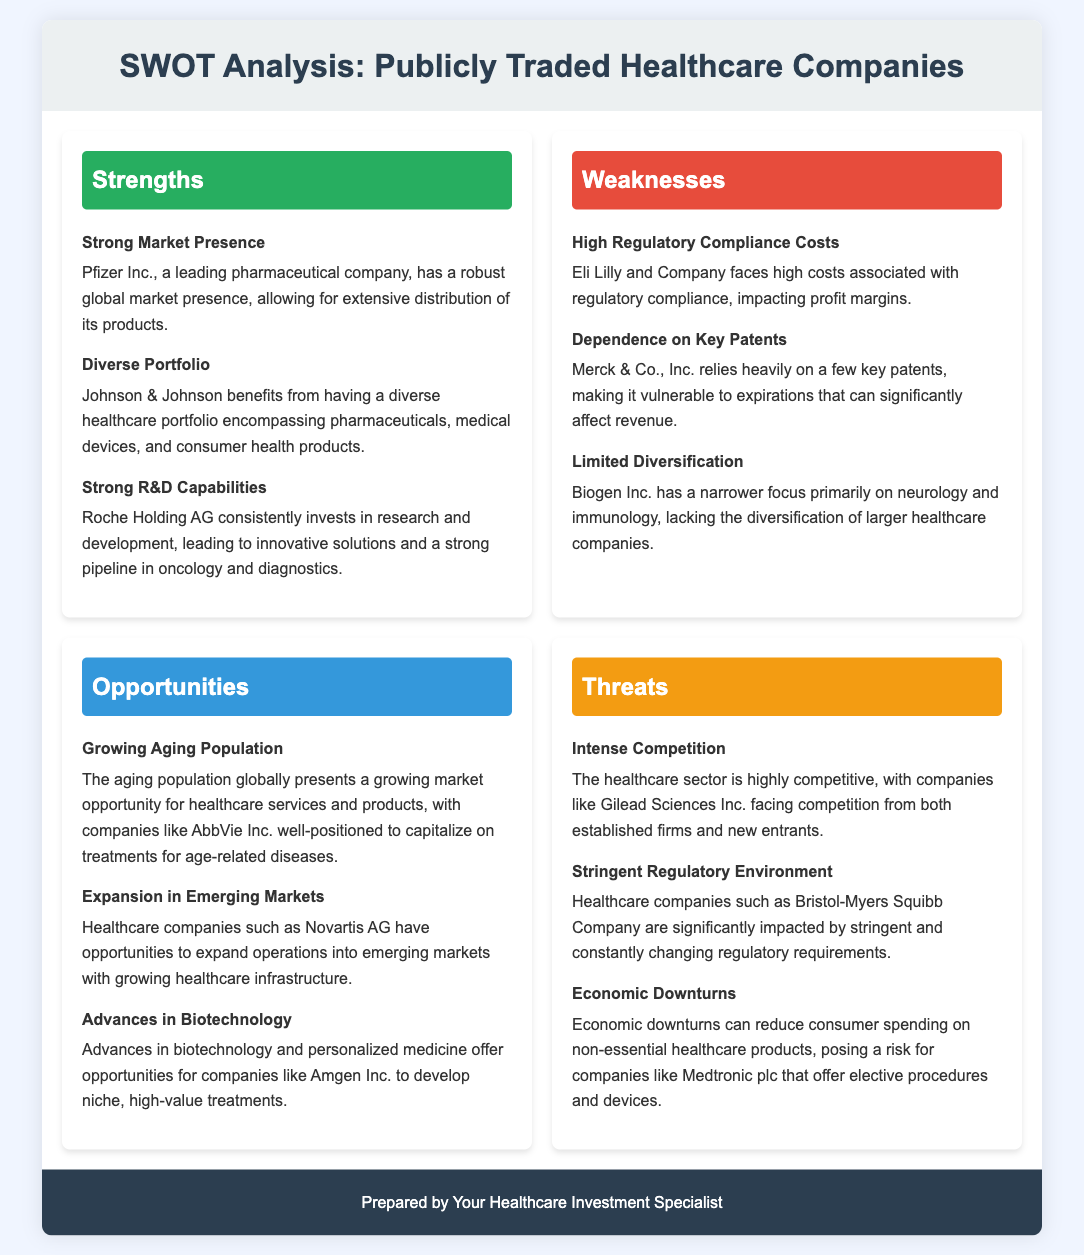What company has a strong market presence? Pfizer Inc. is mentioned as a leading pharmaceutical company with a robust global market presence.
Answer: Pfizer Inc Which company benefits from a diverse healthcare portfolio? Johnson & Johnson is highlighted for its diverse healthcare portfolio encompassing various sectors.
Answer: Johnson & Johnson What is a weakness associated with Eli Lilly and Company? The document states that Eli Lilly and Company faces high costs associated with regulatory compliance.
Answer: High Regulatory Compliance Costs Which company relies heavily on a few key patents? Merck & Co., Inc. is noted for its dependence on a few key patents, making it vulnerable to expirations.
Answer: Merck & Co., Inc What opportunity is presented by the aging population? The document indicates that the aging population globally presents a growing market opportunity for healthcare services.
Answer: Growing Aging Population What competitive threat do companies like Gilead Sciences Inc. face? Gilead Sciences Inc. is mentioned as facing intense competition in the healthcare sector.
Answer: Intense Competition What impact do economic downturns have on companies like Medtronic plc? The text suggests that economic downturns can reduce consumer spending on non-essential healthcare products, posing a risk.
Answer: Economic Downturns What is a crucial area for investment highlighted in the opportunities? Advances in biotechnology and personalized medicine present opportunities for healthcare companies.
Answer: Advances in Biotechnology What type of environment do healthcare companies like Bristol-Myers Squibb Company operate in? The document states that healthcare companies are significantly impacted by a stringent regulatory environment.
Answer: Stringent Regulatory Environment 